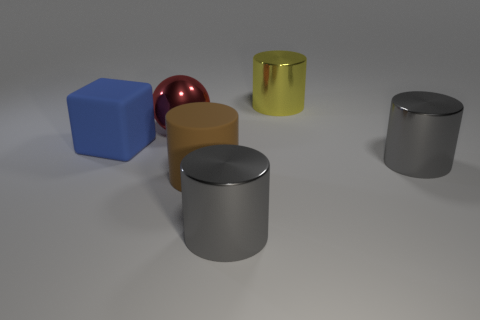Add 1 blue rubber spheres. How many objects exist? 7 Subtract all balls. How many objects are left? 5 Subtract 0 gray spheres. How many objects are left? 6 Subtract all small gray metallic blocks. Subtract all metallic balls. How many objects are left? 5 Add 3 large blue objects. How many large blue objects are left? 4 Add 4 yellow things. How many yellow things exist? 5 